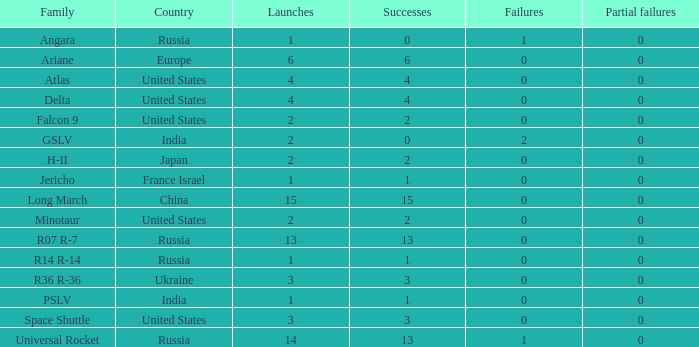What is the partial collapse for the country of russia, and a failure bigger than 0, and a family of angara, and a launch higher than 1? None. 